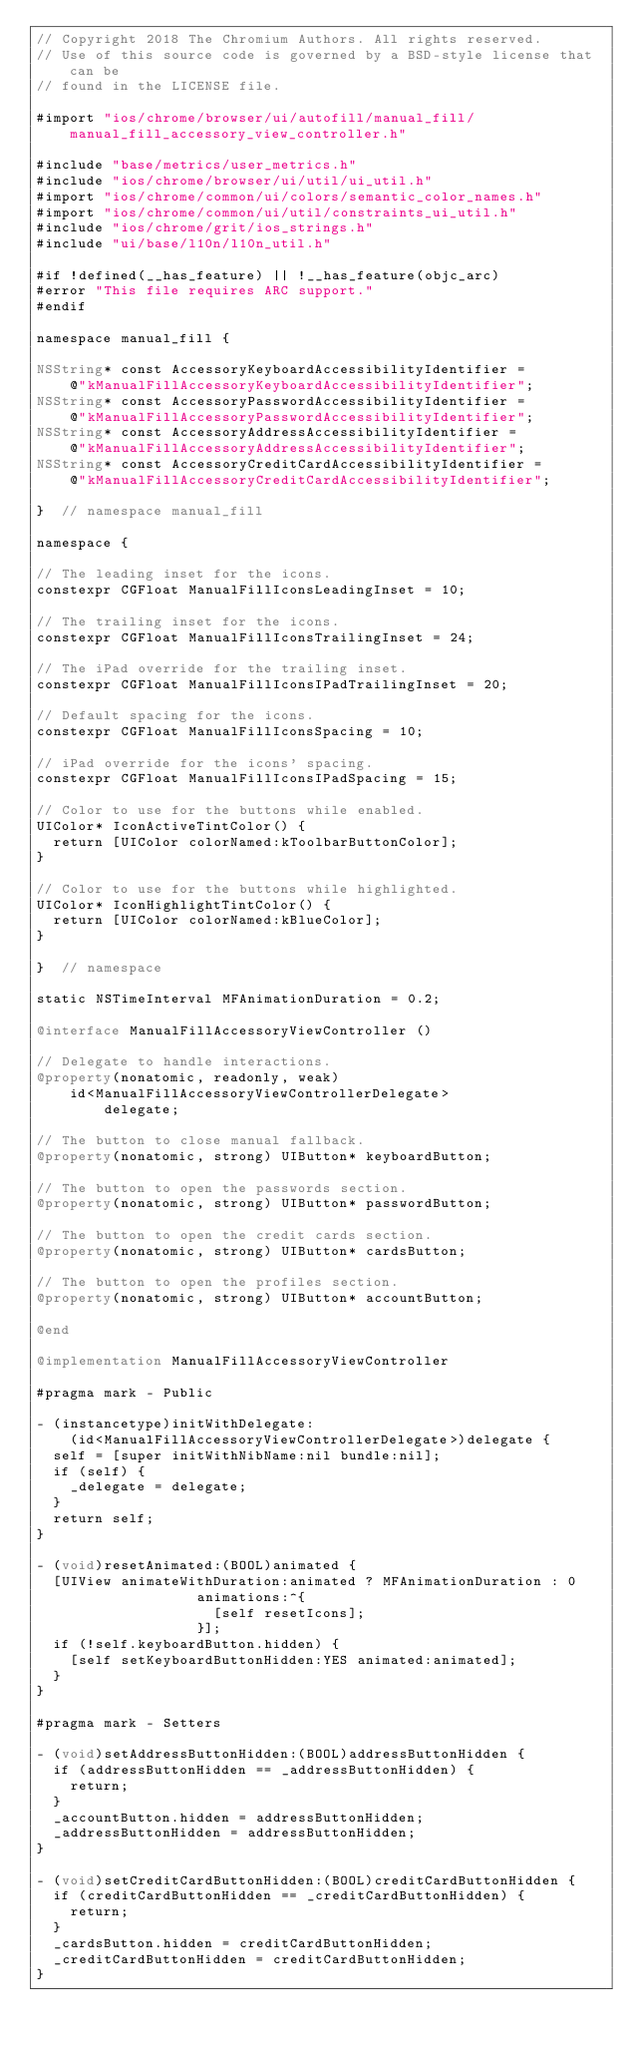Convert code to text. <code><loc_0><loc_0><loc_500><loc_500><_ObjectiveC_>// Copyright 2018 The Chromium Authors. All rights reserved.
// Use of this source code is governed by a BSD-style license that can be
// found in the LICENSE file.

#import "ios/chrome/browser/ui/autofill/manual_fill/manual_fill_accessory_view_controller.h"

#include "base/metrics/user_metrics.h"
#include "ios/chrome/browser/ui/util/ui_util.h"
#import "ios/chrome/common/ui/colors/semantic_color_names.h"
#import "ios/chrome/common/ui/util/constraints_ui_util.h"
#include "ios/chrome/grit/ios_strings.h"
#include "ui/base/l10n/l10n_util.h"

#if !defined(__has_feature) || !__has_feature(objc_arc)
#error "This file requires ARC support."
#endif

namespace manual_fill {

NSString* const AccessoryKeyboardAccessibilityIdentifier =
    @"kManualFillAccessoryKeyboardAccessibilityIdentifier";
NSString* const AccessoryPasswordAccessibilityIdentifier =
    @"kManualFillAccessoryPasswordAccessibilityIdentifier";
NSString* const AccessoryAddressAccessibilityIdentifier =
    @"kManualFillAccessoryAddressAccessibilityIdentifier";
NSString* const AccessoryCreditCardAccessibilityIdentifier =
    @"kManualFillAccessoryCreditCardAccessibilityIdentifier";

}  // namespace manual_fill

namespace {

// The leading inset for the icons.
constexpr CGFloat ManualFillIconsLeadingInset = 10;

// The trailing inset for the icons.
constexpr CGFloat ManualFillIconsTrailingInset = 24;

// The iPad override for the trailing inset.
constexpr CGFloat ManualFillIconsIPadTrailingInset = 20;

// Default spacing for the icons.
constexpr CGFloat ManualFillIconsSpacing = 10;

// iPad override for the icons' spacing.
constexpr CGFloat ManualFillIconsIPadSpacing = 15;

// Color to use for the buttons while enabled.
UIColor* IconActiveTintColor() {
  return [UIColor colorNamed:kToolbarButtonColor];
}

// Color to use for the buttons while highlighted.
UIColor* IconHighlightTintColor() {
  return [UIColor colorNamed:kBlueColor];
}

}  // namespace

static NSTimeInterval MFAnimationDuration = 0.2;

@interface ManualFillAccessoryViewController ()

// Delegate to handle interactions.
@property(nonatomic, readonly, weak)
    id<ManualFillAccessoryViewControllerDelegate>
        delegate;

// The button to close manual fallback.
@property(nonatomic, strong) UIButton* keyboardButton;

// The button to open the passwords section.
@property(nonatomic, strong) UIButton* passwordButton;

// The button to open the credit cards section.
@property(nonatomic, strong) UIButton* cardsButton;

// The button to open the profiles section.
@property(nonatomic, strong) UIButton* accountButton;

@end

@implementation ManualFillAccessoryViewController

#pragma mark - Public

- (instancetype)initWithDelegate:
    (id<ManualFillAccessoryViewControllerDelegate>)delegate {
  self = [super initWithNibName:nil bundle:nil];
  if (self) {
    _delegate = delegate;
  }
  return self;
}

- (void)resetAnimated:(BOOL)animated {
  [UIView animateWithDuration:animated ? MFAnimationDuration : 0
                   animations:^{
                     [self resetIcons];
                   }];
  if (!self.keyboardButton.hidden) {
    [self setKeyboardButtonHidden:YES animated:animated];
  }
}

#pragma mark - Setters

- (void)setAddressButtonHidden:(BOOL)addressButtonHidden {
  if (addressButtonHidden == _addressButtonHidden) {
    return;
  }
  _accountButton.hidden = addressButtonHidden;
  _addressButtonHidden = addressButtonHidden;
}

- (void)setCreditCardButtonHidden:(BOOL)creditCardButtonHidden {
  if (creditCardButtonHidden == _creditCardButtonHidden) {
    return;
  }
  _cardsButton.hidden = creditCardButtonHidden;
  _creditCardButtonHidden = creditCardButtonHidden;
}
</code> 